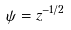<formula> <loc_0><loc_0><loc_500><loc_500>\psi = z ^ { - 1 / 2 }</formula> 